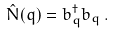Convert formula to latex. <formula><loc_0><loc_0><loc_500><loc_500>\hat { N } ( q ) = b ^ { \dag } _ { q } b _ { q } \, .</formula> 